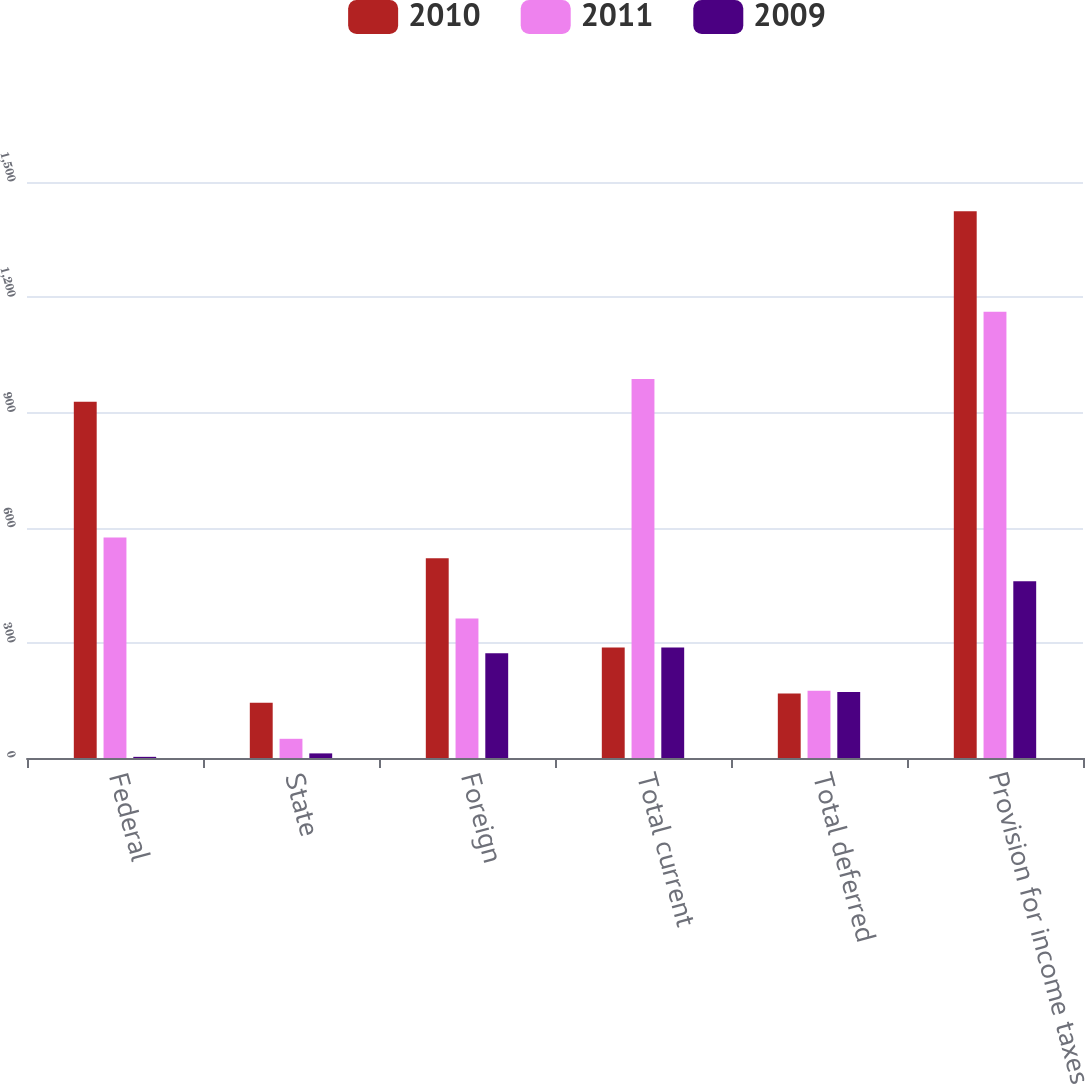Convert chart. <chart><loc_0><loc_0><loc_500><loc_500><stacked_bar_chart><ecel><fcel>Federal<fcel>State<fcel>Foreign<fcel>Total current<fcel>Total deferred<fcel>Provision for income taxes<nl><fcel>2010<fcel>928<fcel>144<fcel>520<fcel>288<fcel>168<fcel>1424<nl><fcel>2011<fcel>574<fcel>50<fcel>363<fcel>987<fcel>175<fcel>1162<nl><fcel>2009<fcel>3<fcel>12<fcel>273<fcel>288<fcel>172<fcel>460<nl></chart> 